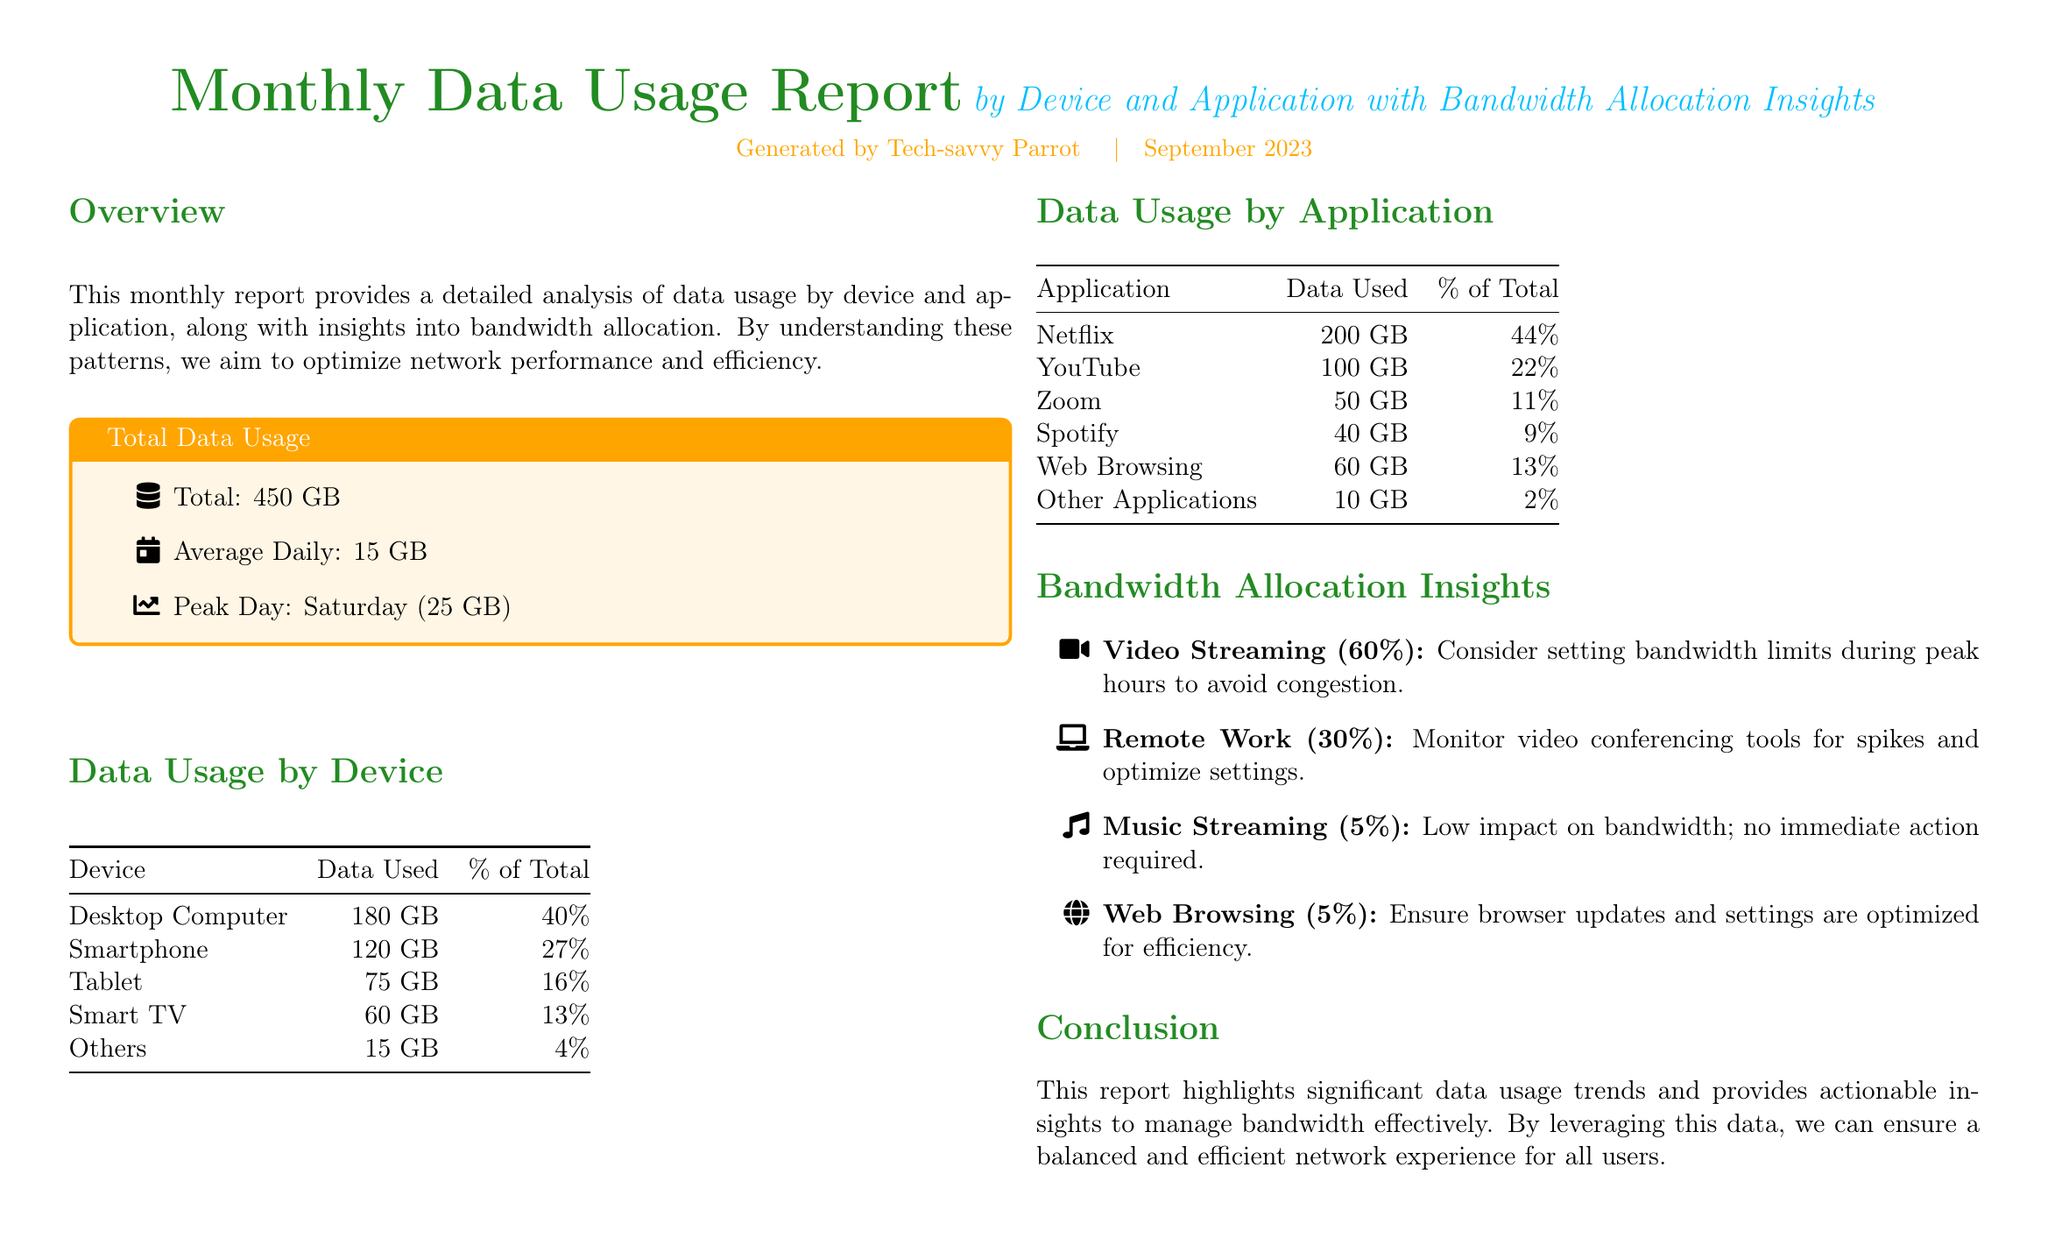What is the total data usage? The total data usage is provided in the "Total Data Usage" section of the report.
Answer: 450 GB What device used the most data? The table for "Data Usage by Device" indicates the device with the highest data usage.
Answer: Desktop Computer What percentage of total data did streaming applications use? The "Data Usage by Application" section lists the percentage for the main application categories, which includes Netflix and YouTube.
Answer: 66% Which application consumed the least data? In the "Data Usage by Application" table, the application with the least data usage is identified.
Answer: Other Applications What was the average daily data usage? The report's overview section states the average daily data usage figure.
Answer: 15 GB What is the peak day for data usage? The "Total Data Usage" section notes the peak day of usage in terms of data consumed.
Answer: Saturday What is the bandwidth allocation percentage for video streaming? The "Bandwidth Allocation Insights" section provides detailed percentages for different application categories.
Answer: 60% How much data did Zoom use? The table for "Data Usage by Application" specifies the data used by Zoom.
Answer: 50 GB What is the total percentage of data used by smartphones and tablets? The "Data Usage by Device" shows the percentages for both devices which can be summed to get the total.
Answer: 43% 